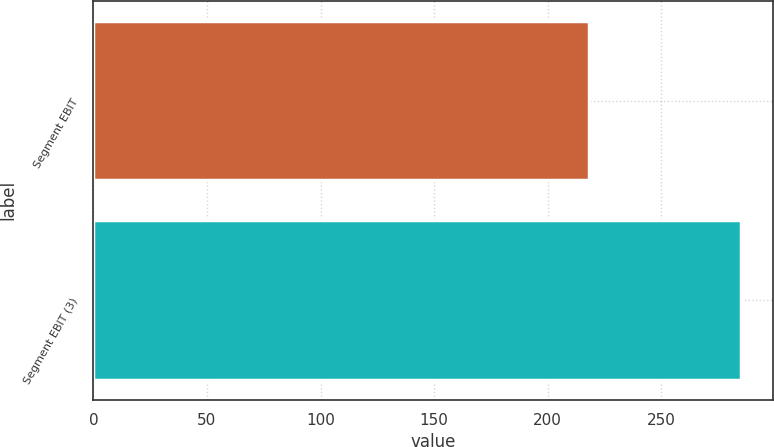<chart> <loc_0><loc_0><loc_500><loc_500><bar_chart><fcel>Segment EBIT<fcel>Segment EBIT (3)<nl><fcel>218<fcel>285<nl></chart> 